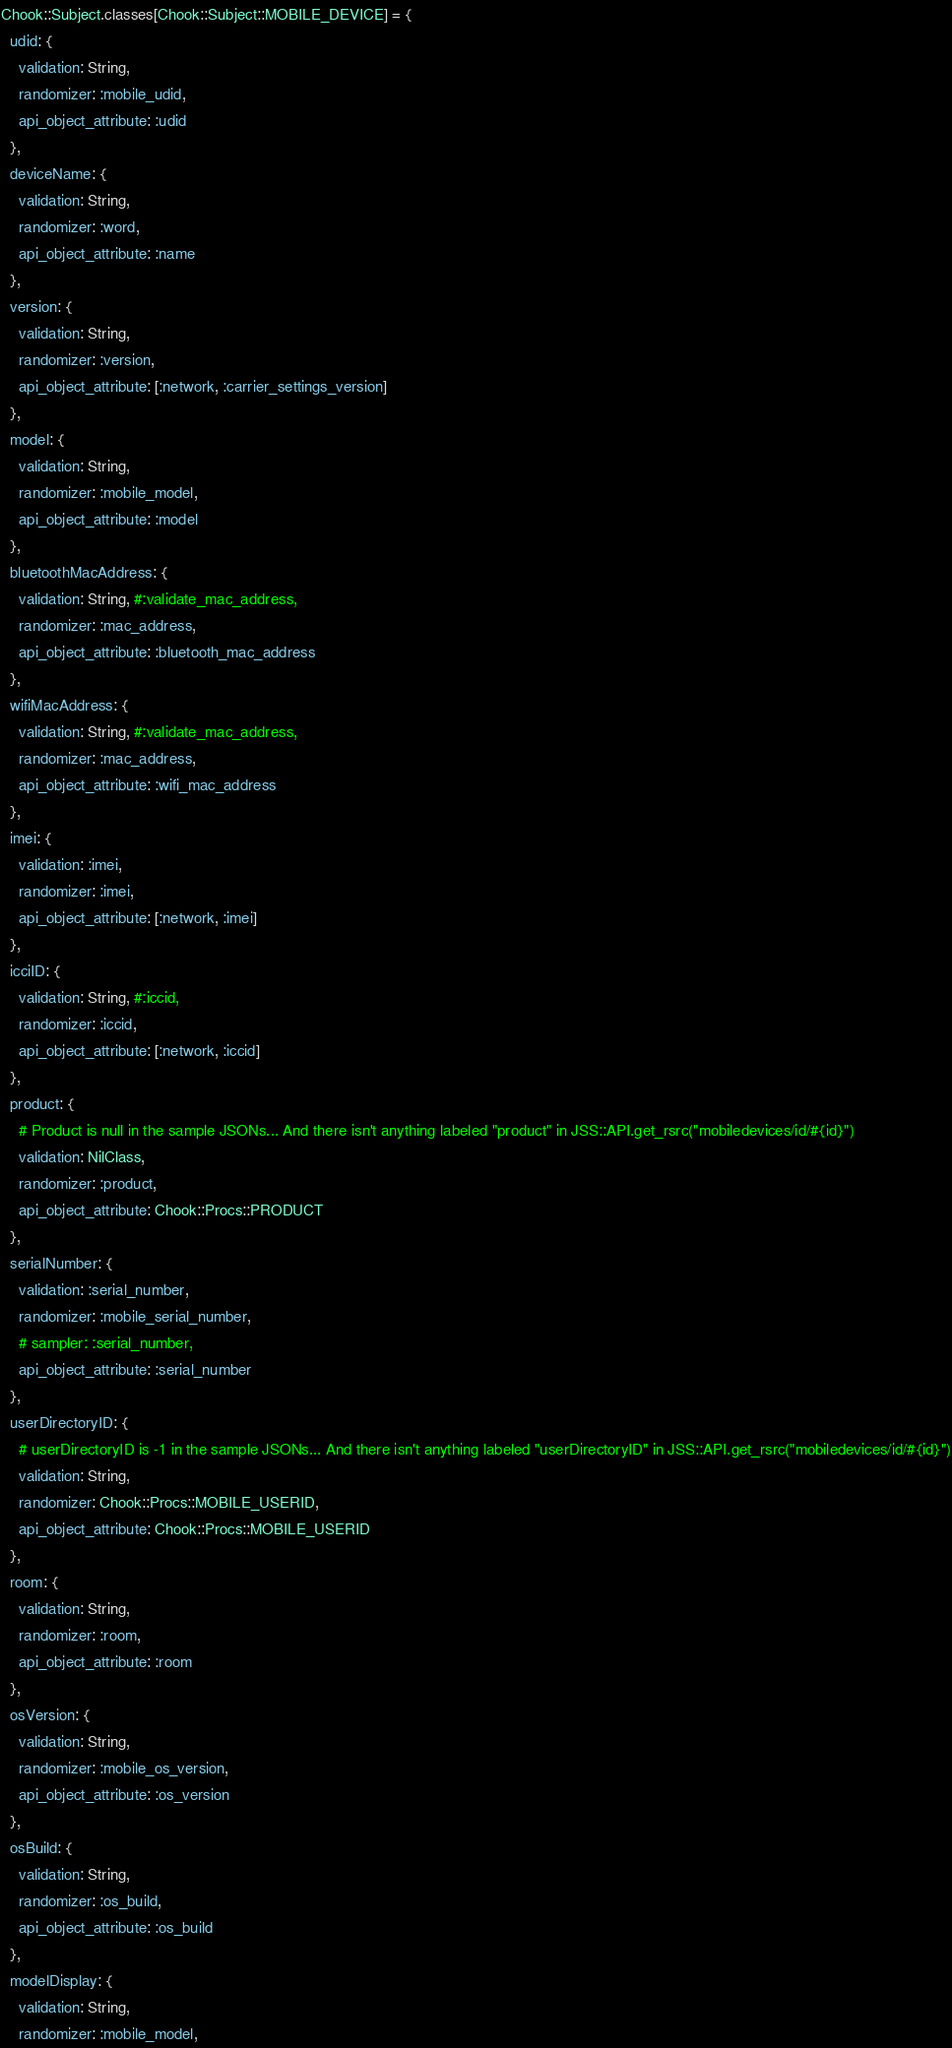Convert code to text. <code><loc_0><loc_0><loc_500><loc_500><_Ruby_>
Chook::Subject.classes[Chook::Subject::MOBILE_DEVICE] = {
  udid: {
    validation: String,
    randomizer: :mobile_udid,
    api_object_attribute: :udid
  },
  deviceName: {
    validation: String,
    randomizer: :word,
    api_object_attribute: :name
  },
  version: {
    validation: String,
    randomizer: :version,
    api_object_attribute: [:network, :carrier_settings_version]
  },
  model: {
    validation: String,
    randomizer: :mobile_model,
    api_object_attribute: :model
  },
  bluetoothMacAddress: {
    validation: String, #:validate_mac_address,
    randomizer: :mac_address,
    api_object_attribute: :bluetooth_mac_address
  },
  wifiMacAddress: {
    validation: String, #:validate_mac_address,
    randomizer: :mac_address,
    api_object_attribute: :wifi_mac_address
  },
  imei: {
    validation: :imei,
    randomizer: :imei,
    api_object_attribute: [:network, :imei]
  },
  icciID: {
    validation: String, #:iccid,
    randomizer: :iccid,
    api_object_attribute: [:network, :iccid]
  },
  product: {
    # Product is null in the sample JSONs... And there isn't anything labeled "product" in JSS::API.get_rsrc("mobiledevices/id/#{id}")
    validation: NilClass,
    randomizer: :product,
    api_object_attribute: Chook::Procs::PRODUCT
  },
  serialNumber: {
    validation: :serial_number,
    randomizer: :mobile_serial_number,
    # sampler: :serial_number,
    api_object_attribute: :serial_number
  },
  userDirectoryID: {
    # userDirectoryID is -1 in the sample JSONs... And there isn't anything labeled "userDirectoryID" in JSS::API.get_rsrc("mobiledevices/id/#{id}")
    validation: String,
    randomizer: Chook::Procs::MOBILE_USERID,
    api_object_attribute: Chook::Procs::MOBILE_USERID
  },
  room: {
    validation: String,
    randomizer: :room,
    api_object_attribute: :room
  },
  osVersion: {
    validation: String,
    randomizer: :mobile_os_version,
    api_object_attribute: :os_version
  },
  osBuild: {
    validation: String,
    randomizer: :os_build,
    api_object_attribute: :os_build
  },
  modelDisplay: {
    validation: String,
    randomizer: :mobile_model,</code> 